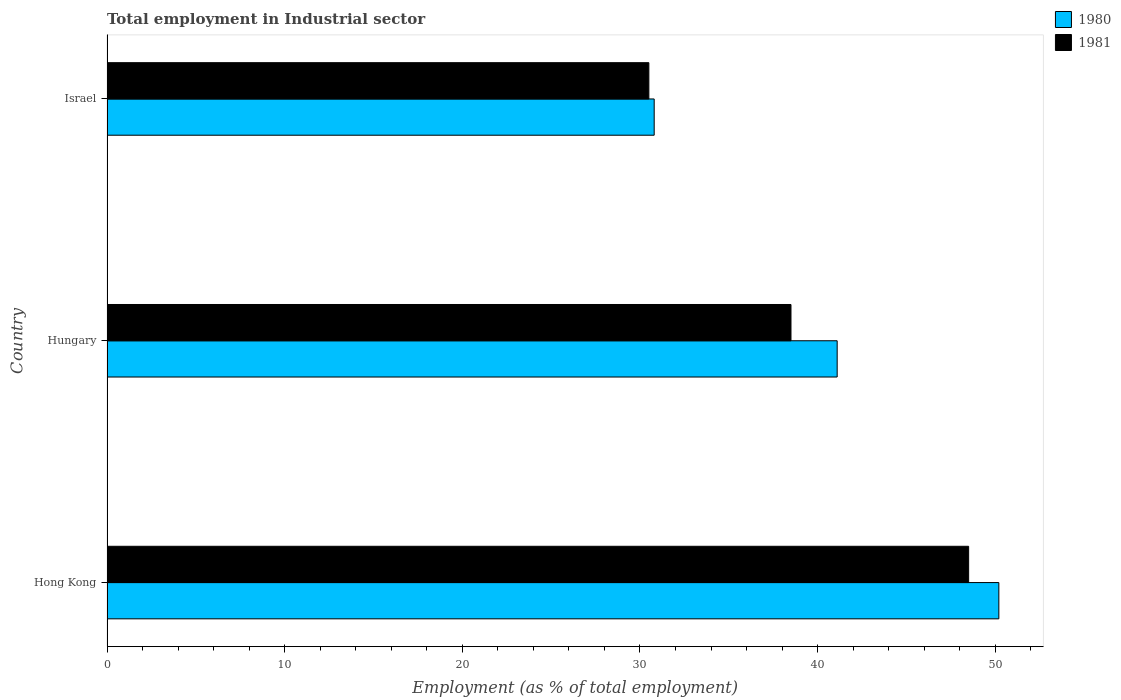How many groups of bars are there?
Ensure brevity in your answer.  3. Are the number of bars per tick equal to the number of legend labels?
Give a very brief answer. Yes. What is the label of the 1st group of bars from the top?
Provide a succinct answer. Israel. What is the employment in industrial sector in 1980 in Hong Kong?
Your answer should be compact. 50.2. Across all countries, what is the maximum employment in industrial sector in 1980?
Provide a succinct answer. 50.2. Across all countries, what is the minimum employment in industrial sector in 1981?
Make the answer very short. 30.5. In which country was the employment in industrial sector in 1981 maximum?
Give a very brief answer. Hong Kong. In which country was the employment in industrial sector in 1980 minimum?
Give a very brief answer. Israel. What is the total employment in industrial sector in 1981 in the graph?
Provide a succinct answer. 117.5. What is the difference between the employment in industrial sector in 1980 in Hong Kong and that in Hungary?
Give a very brief answer. 9.1. What is the difference between the employment in industrial sector in 1981 in Hong Kong and the employment in industrial sector in 1980 in Hungary?
Keep it short and to the point. 7.4. What is the average employment in industrial sector in 1980 per country?
Provide a short and direct response. 40.7. What is the difference between the employment in industrial sector in 1980 and employment in industrial sector in 1981 in Hong Kong?
Your answer should be compact. 1.7. What is the ratio of the employment in industrial sector in 1980 in Hong Kong to that in Hungary?
Keep it short and to the point. 1.22. Is the employment in industrial sector in 1981 in Hungary less than that in Israel?
Offer a terse response. No. What is the difference between the highest and the lowest employment in industrial sector in 1981?
Give a very brief answer. 18. Is the sum of the employment in industrial sector in 1980 in Hungary and Israel greater than the maximum employment in industrial sector in 1981 across all countries?
Your response must be concise. Yes. What does the 1st bar from the top in Israel represents?
Your response must be concise. 1981. What does the 2nd bar from the bottom in Israel represents?
Your answer should be very brief. 1981. How many bars are there?
Provide a short and direct response. 6. Are all the bars in the graph horizontal?
Ensure brevity in your answer.  Yes. Are the values on the major ticks of X-axis written in scientific E-notation?
Your response must be concise. No. How are the legend labels stacked?
Your answer should be compact. Vertical. What is the title of the graph?
Your answer should be very brief. Total employment in Industrial sector. What is the label or title of the X-axis?
Give a very brief answer. Employment (as % of total employment). What is the label or title of the Y-axis?
Make the answer very short. Country. What is the Employment (as % of total employment) in 1980 in Hong Kong?
Provide a succinct answer. 50.2. What is the Employment (as % of total employment) in 1981 in Hong Kong?
Your answer should be compact. 48.5. What is the Employment (as % of total employment) in 1980 in Hungary?
Provide a succinct answer. 41.1. What is the Employment (as % of total employment) in 1981 in Hungary?
Give a very brief answer. 38.5. What is the Employment (as % of total employment) of 1980 in Israel?
Offer a terse response. 30.8. What is the Employment (as % of total employment) of 1981 in Israel?
Your response must be concise. 30.5. Across all countries, what is the maximum Employment (as % of total employment) of 1980?
Your answer should be compact. 50.2. Across all countries, what is the maximum Employment (as % of total employment) in 1981?
Provide a succinct answer. 48.5. Across all countries, what is the minimum Employment (as % of total employment) in 1980?
Your response must be concise. 30.8. Across all countries, what is the minimum Employment (as % of total employment) of 1981?
Provide a succinct answer. 30.5. What is the total Employment (as % of total employment) of 1980 in the graph?
Keep it short and to the point. 122.1. What is the total Employment (as % of total employment) of 1981 in the graph?
Your answer should be very brief. 117.5. What is the difference between the Employment (as % of total employment) in 1980 in Hong Kong and that in Hungary?
Give a very brief answer. 9.1. What is the difference between the Employment (as % of total employment) in 1981 in Hong Kong and that in Hungary?
Your answer should be very brief. 10. What is the difference between the Employment (as % of total employment) in 1980 in Hong Kong and that in Israel?
Offer a very short reply. 19.4. What is the difference between the Employment (as % of total employment) of 1981 in Hong Kong and that in Israel?
Your response must be concise. 18. What is the difference between the Employment (as % of total employment) of 1980 in Hungary and that in Israel?
Ensure brevity in your answer.  10.3. What is the difference between the Employment (as % of total employment) in 1980 in Hong Kong and the Employment (as % of total employment) in 1981 in Hungary?
Offer a very short reply. 11.7. What is the difference between the Employment (as % of total employment) in 1980 in Hong Kong and the Employment (as % of total employment) in 1981 in Israel?
Offer a very short reply. 19.7. What is the average Employment (as % of total employment) of 1980 per country?
Your answer should be very brief. 40.7. What is the average Employment (as % of total employment) of 1981 per country?
Offer a terse response. 39.17. What is the difference between the Employment (as % of total employment) of 1980 and Employment (as % of total employment) of 1981 in Hong Kong?
Your answer should be very brief. 1.7. What is the difference between the Employment (as % of total employment) of 1980 and Employment (as % of total employment) of 1981 in Hungary?
Your response must be concise. 2.6. What is the difference between the Employment (as % of total employment) of 1980 and Employment (as % of total employment) of 1981 in Israel?
Keep it short and to the point. 0.3. What is the ratio of the Employment (as % of total employment) of 1980 in Hong Kong to that in Hungary?
Keep it short and to the point. 1.22. What is the ratio of the Employment (as % of total employment) of 1981 in Hong Kong to that in Hungary?
Provide a short and direct response. 1.26. What is the ratio of the Employment (as % of total employment) of 1980 in Hong Kong to that in Israel?
Make the answer very short. 1.63. What is the ratio of the Employment (as % of total employment) of 1981 in Hong Kong to that in Israel?
Provide a short and direct response. 1.59. What is the ratio of the Employment (as % of total employment) of 1980 in Hungary to that in Israel?
Keep it short and to the point. 1.33. What is the ratio of the Employment (as % of total employment) of 1981 in Hungary to that in Israel?
Offer a very short reply. 1.26. What is the difference between the highest and the second highest Employment (as % of total employment) of 1980?
Provide a short and direct response. 9.1. What is the difference between the highest and the second highest Employment (as % of total employment) in 1981?
Your response must be concise. 10. 